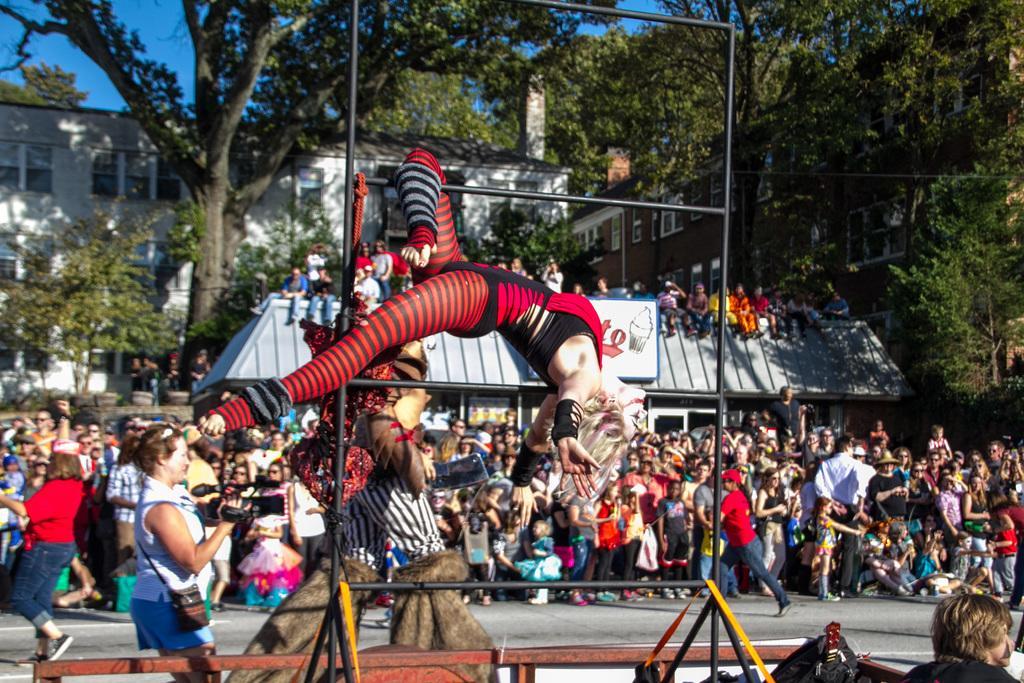Could you give a brief overview of what you see in this image? In this image, in the middle, we can see a woman lying on the metal rod. In the right corner, we can see a man and a bag. On the left side, we can also see a woman holding a camera. On the left side, we can also see another woman wearing a red color dress is walking on the road. In the middle of the image, we can see a person walking. In the background, we can see a group of people, house. On the house, we can see a group of people sitting on the house roof. In the background, we can see a building, glass window, trees. At the top, we can see a sky, at the bottom, we can see a road. 